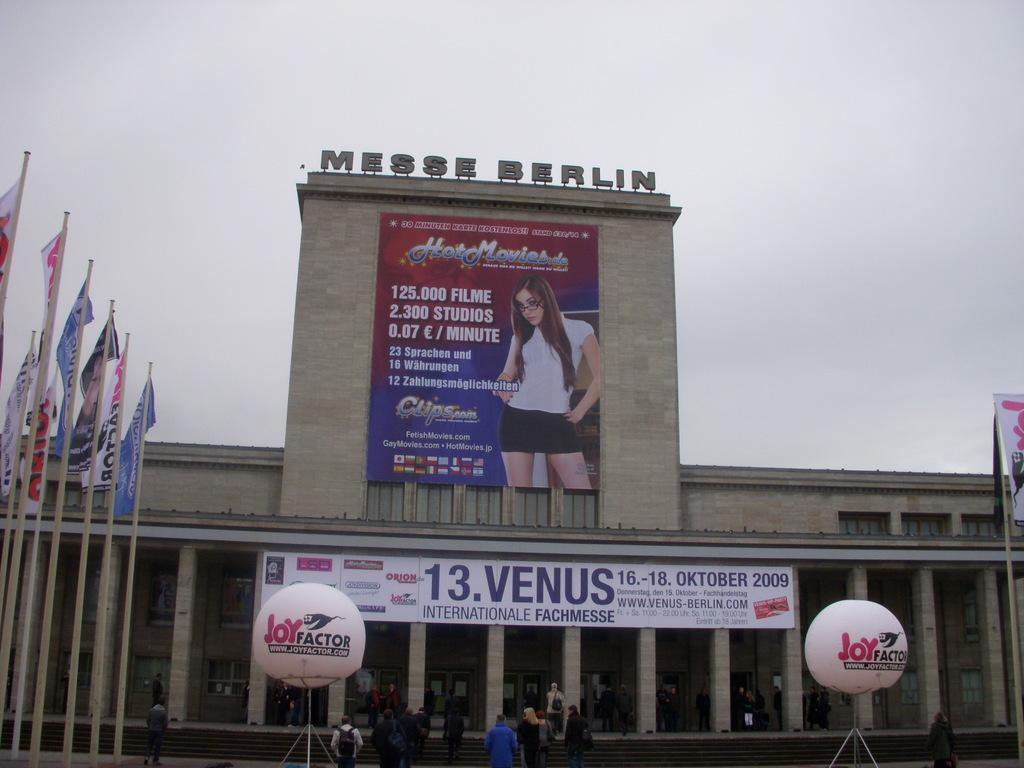Provide a one-sentence caption for the provided image. The Messe Berlin Venue with a post title Hot Movies with and image of a woman on it. 